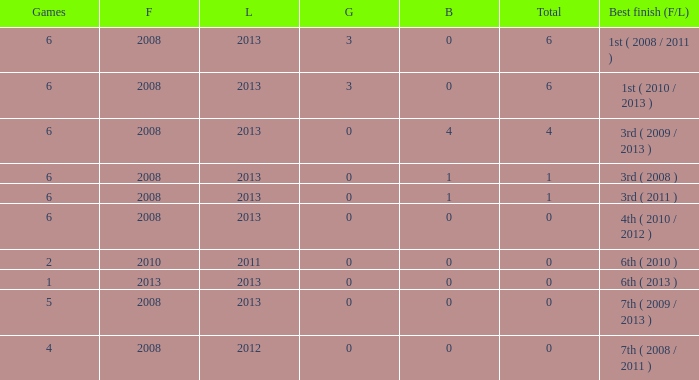What is the latest first year with 0 total medals and over 0 golds? 2008.0. 